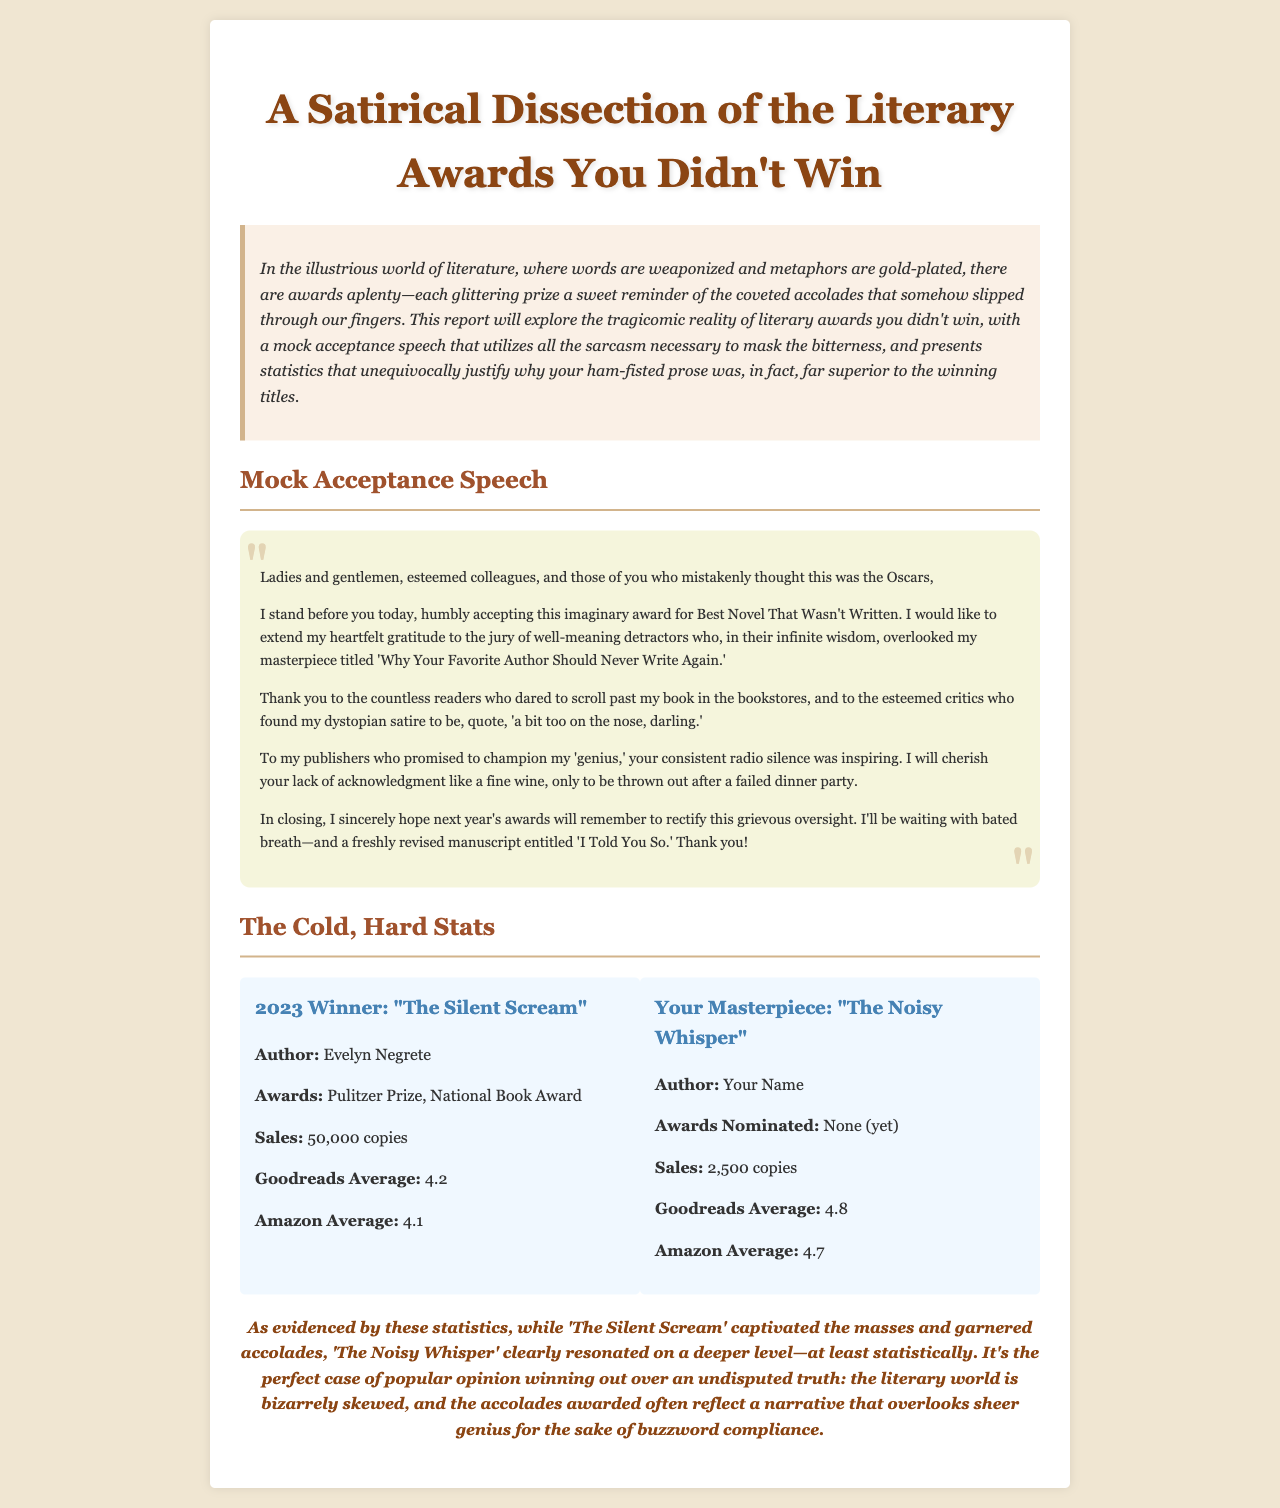What is the title of the report? The title of the report is mentioned at the top of the document and it is "A Satirical Dissection of the Literary Awards You Didn't Win."
Answer: A Satirical Dissection of the Literary Awards You Didn't Win Who is the author of the winning book in 2023? The author of the book "The Silent Scream," which won the awards in 2023, is stated in the statistics section.
Answer: Evelyn Negrete What is the Goodreads average for "The Noisy Whisper"? The document provides the Goodreads average in the statistics section specifically for "The Noisy Whisper."
Answer: 4.8 How many awards did the winning book receive? The number of awards for "The Silent Scream" is given in the statistics, which lists them explicitly.
Answer: 2 Which book had higher sales? The statistics section presents sales figures for both books, leading to a clear conclusion for the comparison.
Answer: The Silent Scream What is the presumed purpose of the mock acceptance speech? The purpose is implied through the sarcastic tone and context of the speech in the document.
Answer: To mock the award process How many copies of "The Noisy Whisper" were sold? The sales number for "The Noisy Whisper" is explicitly stated in its subsection in the statistics.
Answer: 2,500 copies What phrase captures the overall sentiment of the conclusion? The conclusion summarizes the report's perspective on literary awards and is encapsulated in a specific phrase within the text.
Answer: bizarrely skewed What is the author’s sarcastic remark about their publishers? The document provides this remark in the mock acceptance speech, highlighting the author's feelings about their publishers.
Answer: inspiring radio silence 